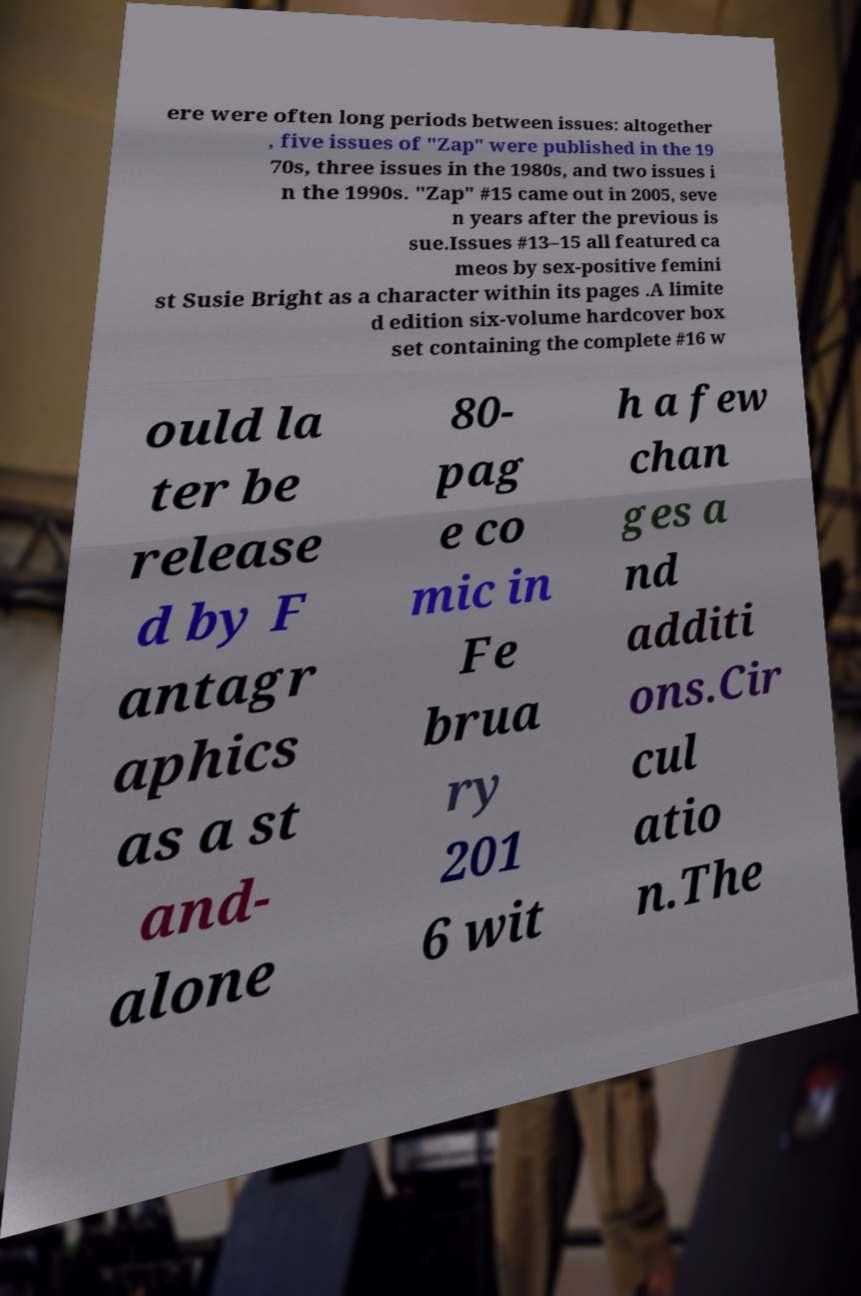Could you assist in decoding the text presented in this image and type it out clearly? ere were often long periods between issues: altogether , five issues of "Zap" were published in the 19 70s, three issues in the 1980s, and two issues i n the 1990s. "Zap" #15 came out in 2005, seve n years after the previous is sue.Issues #13–15 all featured ca meos by sex-positive femini st Susie Bright as a character within its pages .A limite d edition six-volume hardcover box set containing the complete #16 w ould la ter be release d by F antagr aphics as a st and- alone 80- pag e co mic in Fe brua ry 201 6 wit h a few chan ges a nd additi ons.Cir cul atio n.The 